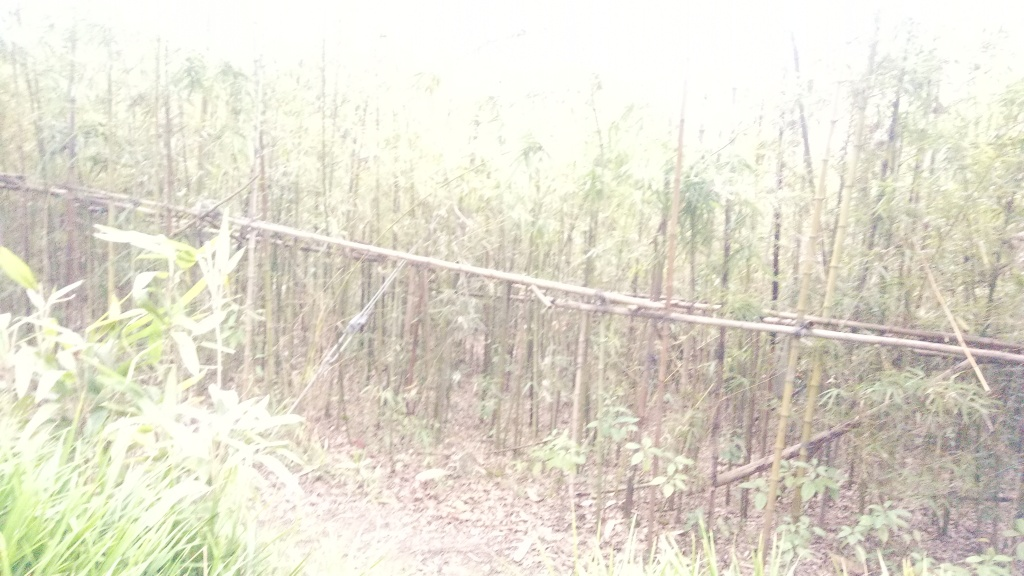Could you describe the environment shown in this image? The image depicts a bamboo forest with tall, slender bamboo stalks. The underbrush is relatively clear, suggesting the area might be managed or frequently traversed. Despite the overexposure and blur, one can make out that it's a lush, green space that could serve as a habitat for a variety of wildlife. 